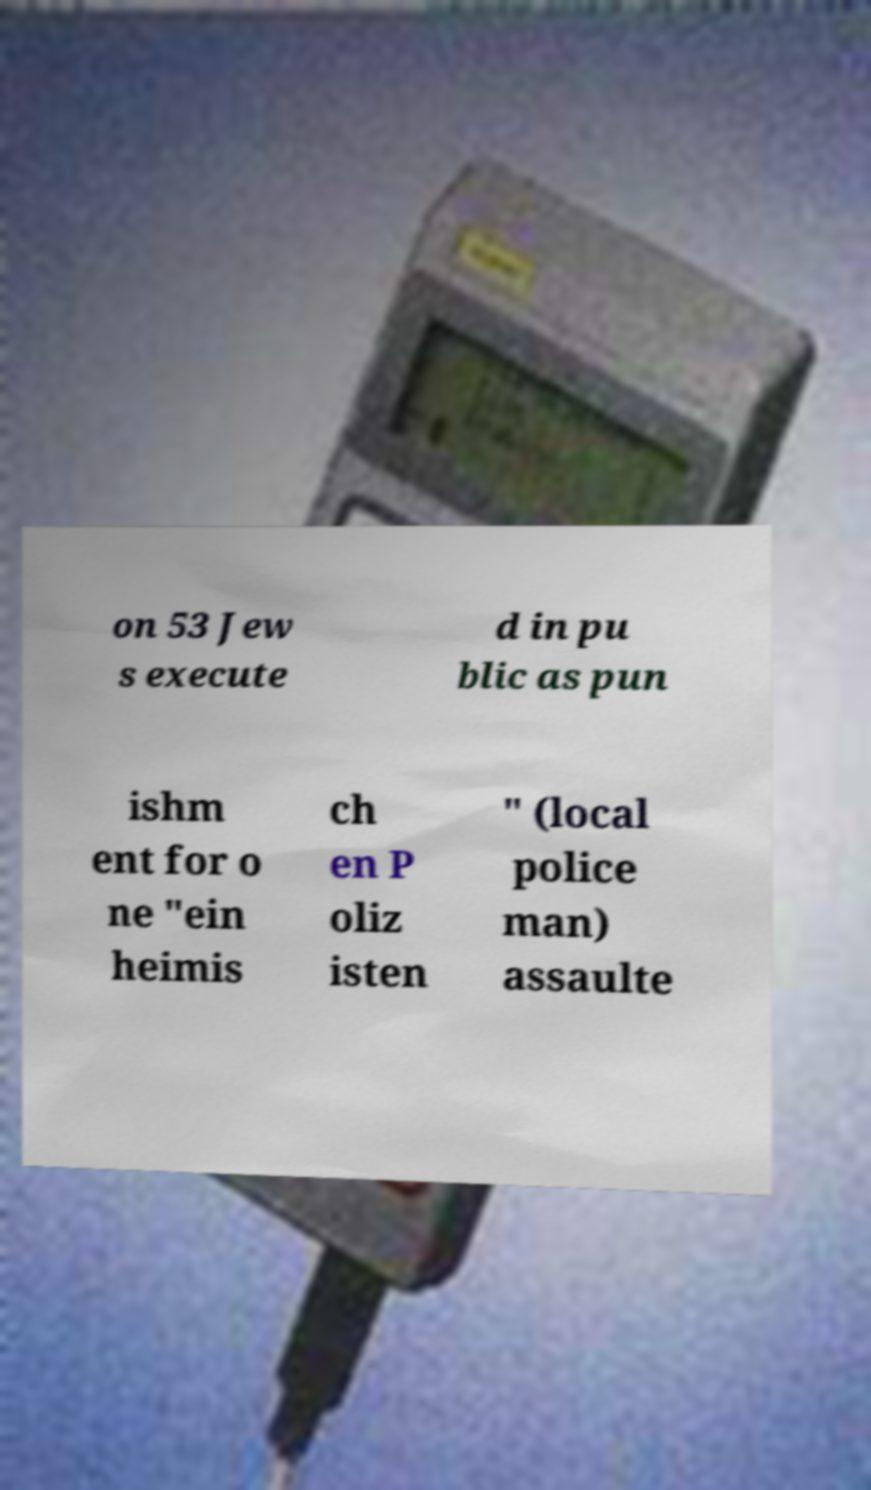Can you read and provide the text displayed in the image?This photo seems to have some interesting text. Can you extract and type it out for me? on 53 Jew s execute d in pu blic as pun ishm ent for o ne "ein heimis ch en P oliz isten " (local police man) assaulte 